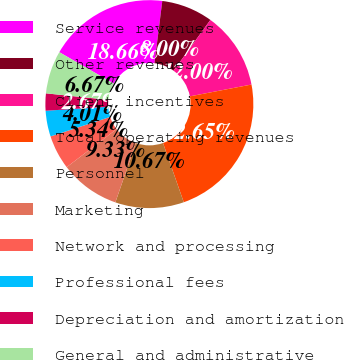<chart> <loc_0><loc_0><loc_500><loc_500><pie_chart><fcel>Service revenues<fcel>Other revenues<fcel>Client incentives<fcel>Total operating revenues<fcel>Personnel<fcel>Marketing<fcel>Network and processing<fcel>Professional fees<fcel>Depreciation and amortization<fcel>General and administrative<nl><fcel>18.66%<fcel>8.0%<fcel>12.0%<fcel>22.65%<fcel>10.67%<fcel>9.33%<fcel>5.34%<fcel>4.01%<fcel>2.67%<fcel>6.67%<nl></chart> 